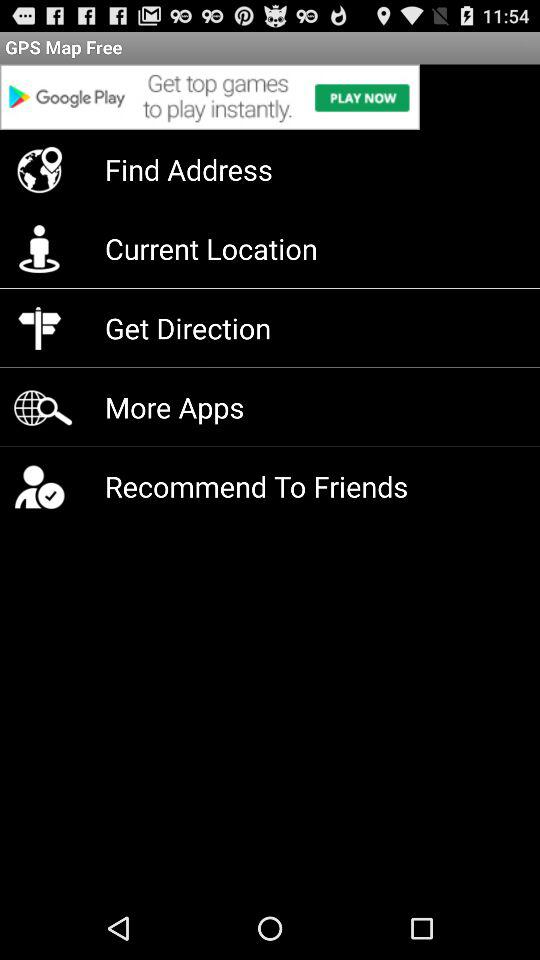How many items are in the bottom menu?
Answer the question using a single word or phrase. 5 